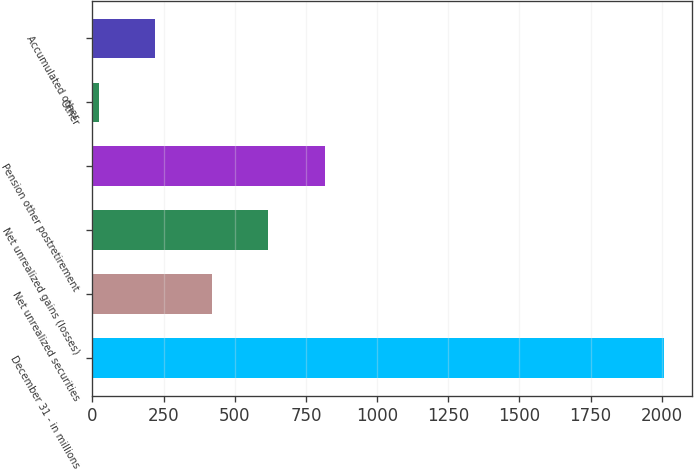Convert chart. <chart><loc_0><loc_0><loc_500><loc_500><bar_chart><fcel>December 31 - in millions<fcel>Net unrealized securities<fcel>Net unrealized gains (losses)<fcel>Pension other postretirement<fcel>Other<fcel>Accumulated other<nl><fcel>2007<fcel>419<fcel>617.5<fcel>816<fcel>22<fcel>220.5<nl></chart> 